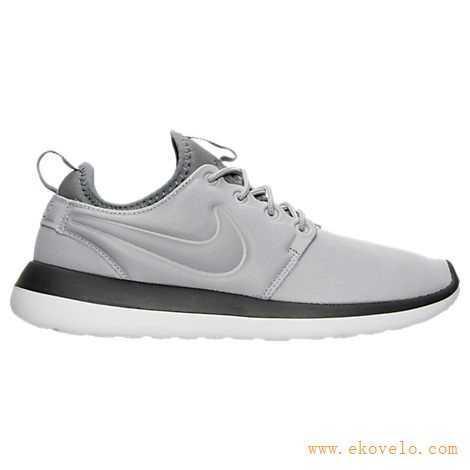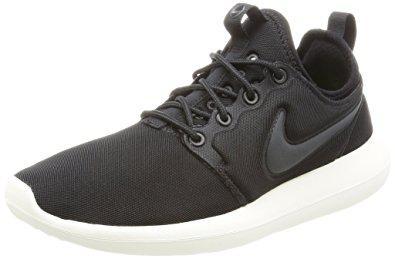The first image is the image on the left, the second image is the image on the right. Assess this claim about the two images: "One of the shoes has a coral pink and white sole.". Correct or not? Answer yes or no. No. The first image is the image on the left, the second image is the image on the right. Examine the images to the left and right. Is the description "There are two shoes, both pointing in the same direction" accurate? Answer yes or no. No. 